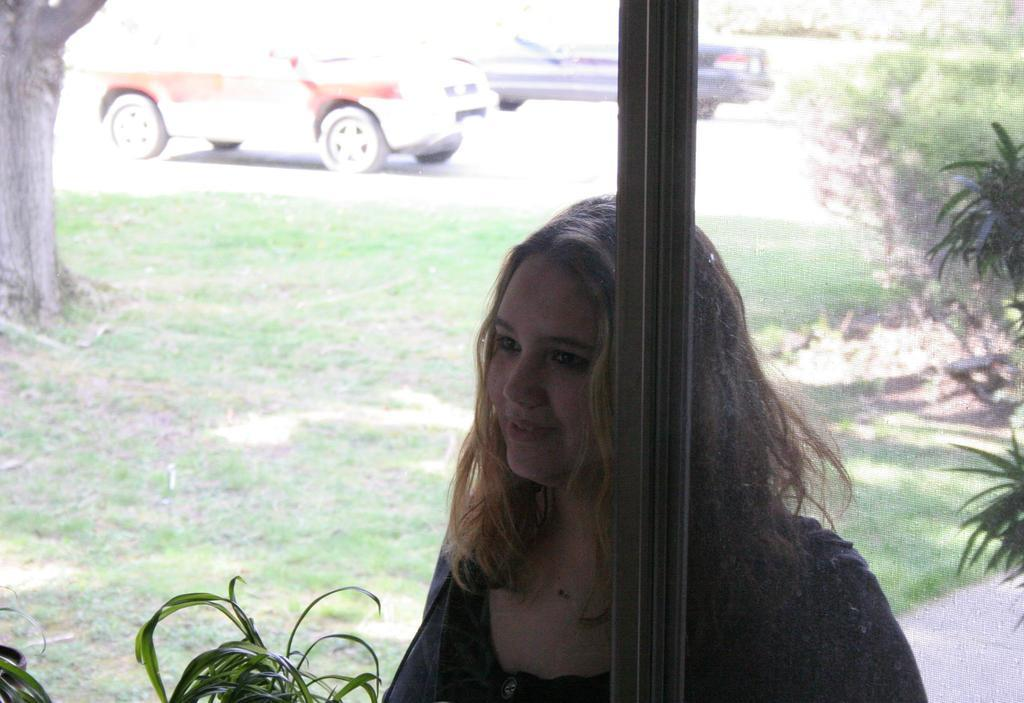What is the woman in the image doing? The woman is standing near a pole in the image. What can be seen on the road in the image? There are vehicles on the road in the image. What type of vegetation is present in the image? There are trees, bushes, plants, and grass in the image. What type of table is visible in the image? There is no table present in the image. How many cars are parked on the grass in the image? There is no mention of cars in the image; only vehicles on the road are mentioned. 